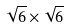<formula> <loc_0><loc_0><loc_500><loc_500>\sqrt { 6 } \times \sqrt { 6 }</formula> 